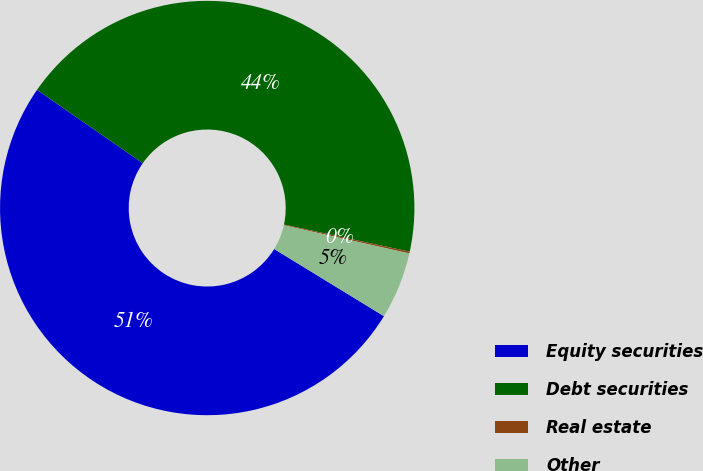Convert chart to OTSL. <chart><loc_0><loc_0><loc_500><loc_500><pie_chart><fcel>Equity securities<fcel>Debt securities<fcel>Real estate<fcel>Other<nl><fcel>50.92%<fcel>43.72%<fcel>0.14%<fcel>5.22%<nl></chart> 